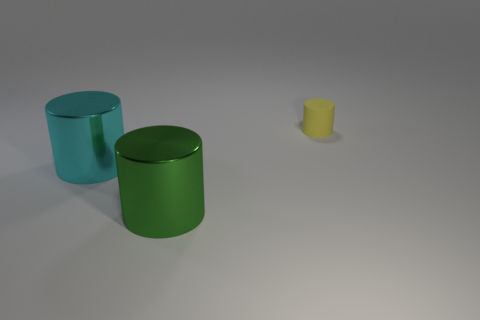Add 1 metal balls. How many objects exist? 4 Subtract 0 purple spheres. How many objects are left? 3 Subtract all green balls. Subtract all cyan metal objects. How many objects are left? 2 Add 1 big objects. How many big objects are left? 3 Add 2 matte blocks. How many matte blocks exist? 2 